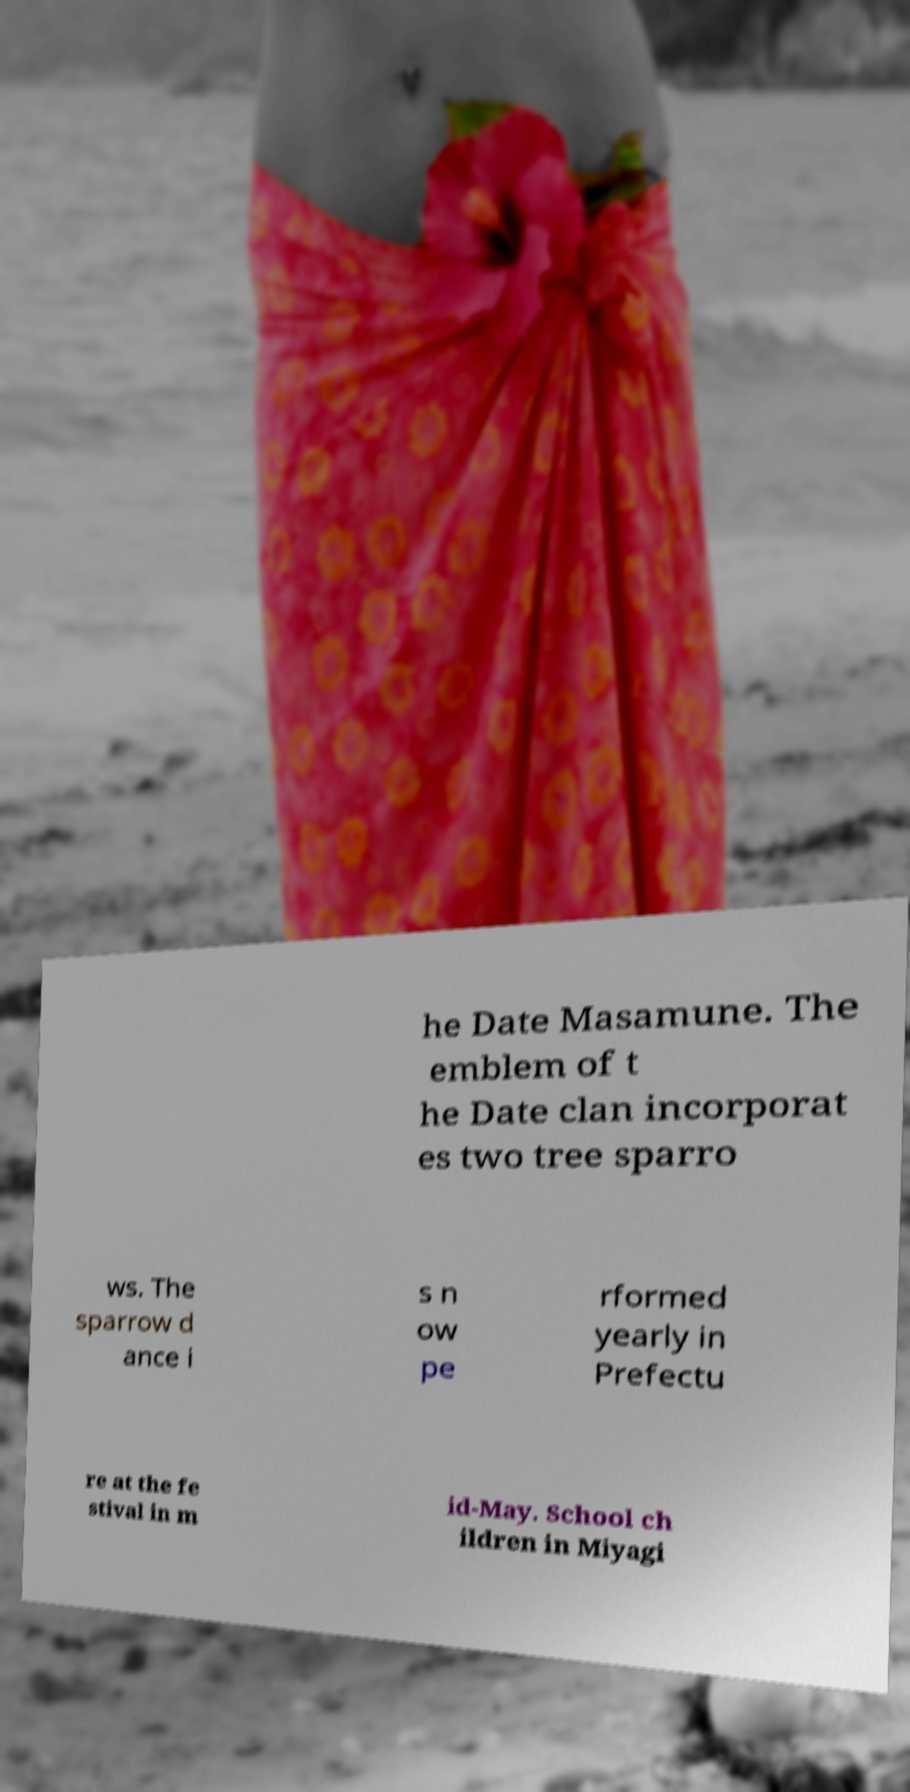I need the written content from this picture converted into text. Can you do that? he Date Masamune. The emblem of t he Date clan incorporat es two tree sparro ws. The sparrow d ance i s n ow pe rformed yearly in Prefectu re at the fe stival in m id-May. School ch ildren in Miyagi 